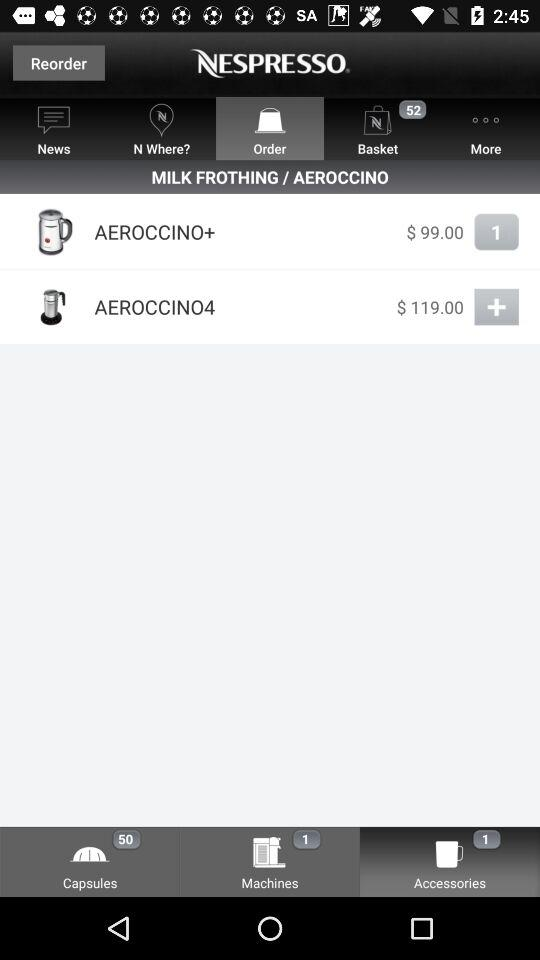How many items are in "Capsules" tab? There are 50 items. 